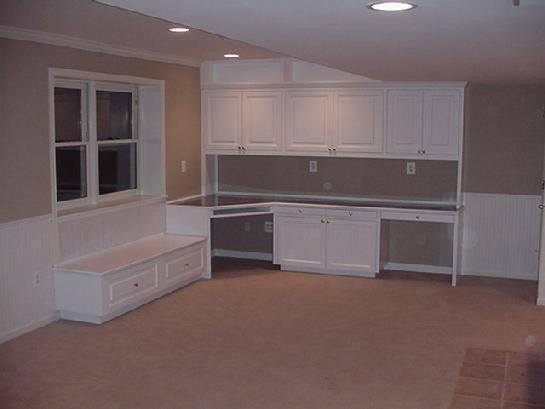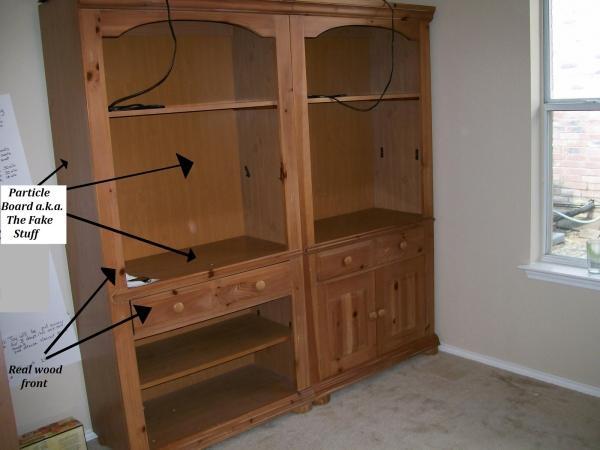The first image is the image on the left, the second image is the image on the right. Analyze the images presented: Is the assertion "In one image, a center desk space has two open upper shelving units on each side with corresponding closed units below." valid? Answer yes or no. No. The first image is the image on the left, the second image is the image on the right. Evaluate the accuracy of this statement regarding the images: "An image shows a chair pulled up to a white desk, which sits under a wall-mounted white shelf unit.". Is it true? Answer yes or no. No. 